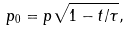<formula> <loc_0><loc_0><loc_500><loc_500>p _ { 0 } = p \sqrt { 1 - t / \tau } ,</formula> 